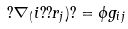Convert formula to latex. <formula><loc_0><loc_0><loc_500><loc_500>? \nabla _ { ( } i ? ? r _ { j } ) ? = \phi g _ { i j }</formula> 